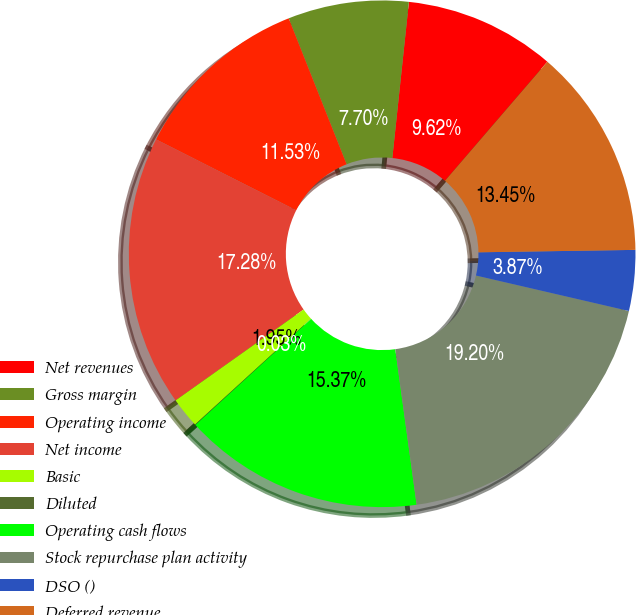Convert chart to OTSL. <chart><loc_0><loc_0><loc_500><loc_500><pie_chart><fcel>Net revenues<fcel>Gross margin<fcel>Operating income<fcel>Net income<fcel>Basic<fcel>Diluted<fcel>Operating cash flows<fcel>Stock repurchase plan activity<fcel>DSO ()<fcel>Deferred revenue<nl><fcel>9.62%<fcel>7.7%<fcel>11.53%<fcel>17.28%<fcel>1.95%<fcel>0.03%<fcel>15.37%<fcel>19.2%<fcel>3.87%<fcel>13.45%<nl></chart> 